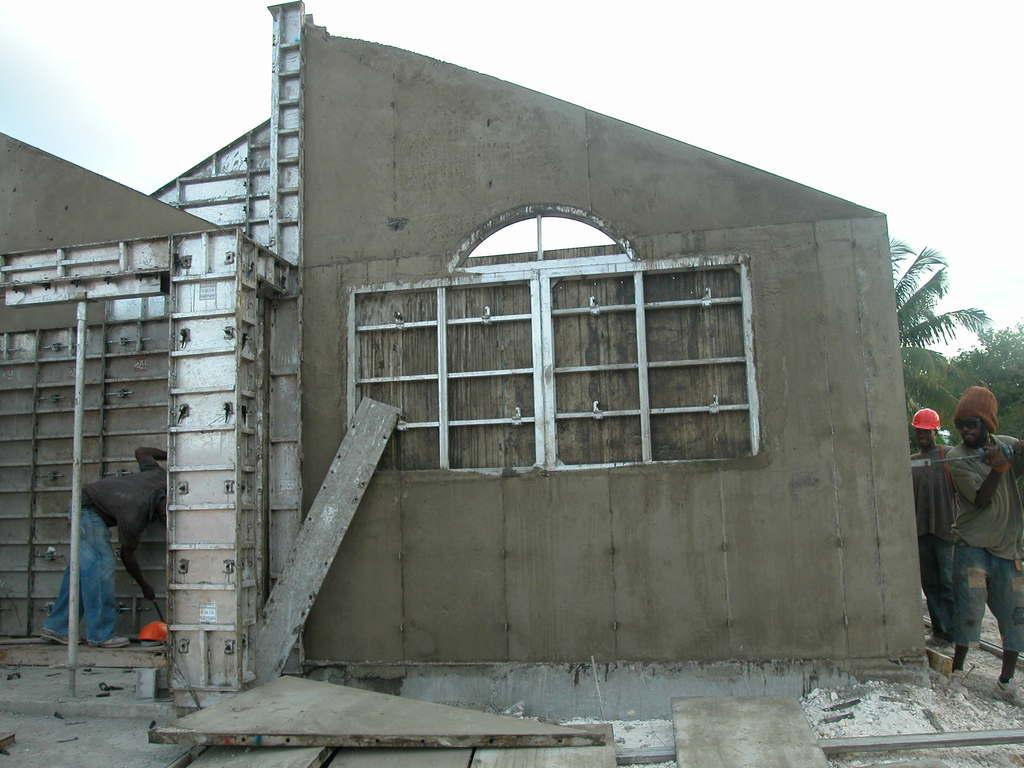How many people are present in the image? There are three persons in the image. What are the persons doing in the image? The persons are constructing a wooden house. What can be seen in the background of the image? There are trees and the sky visible in the background of the image. What type of screw is being used to attach the legs to the wooden house in the image? There is no screw or legs present in the image; it features three persons constructing a wooden house. 